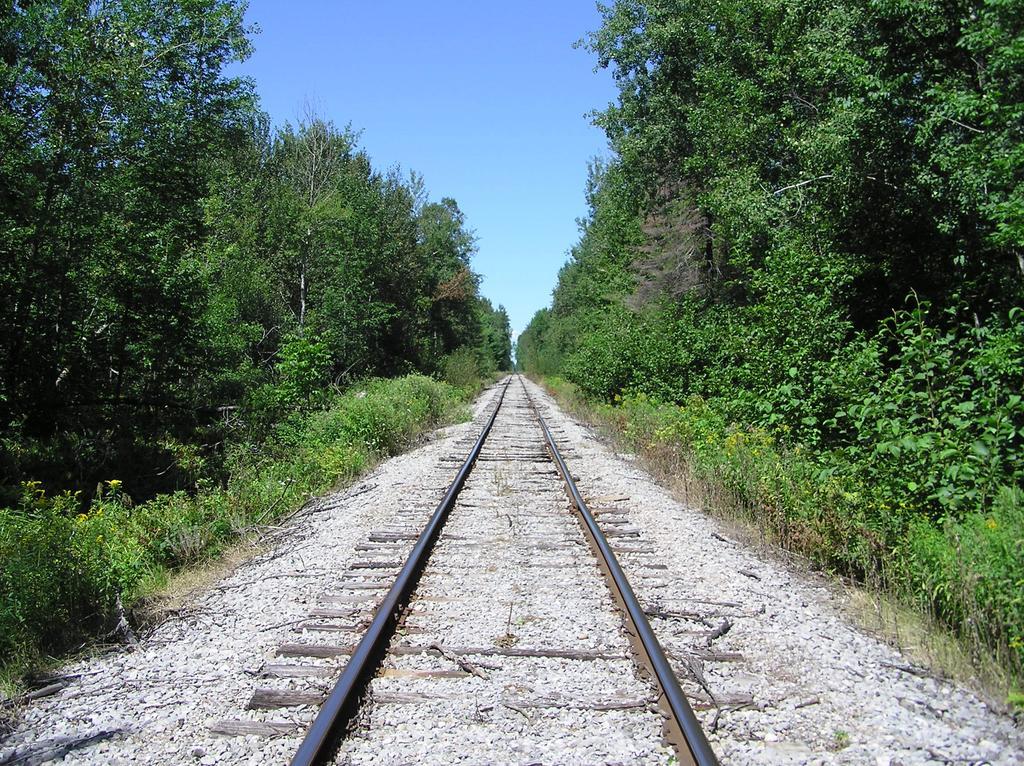In one or two sentences, can you explain what this image depicts? In this picture we can see railway track, beside we can see so many trees and plants. 